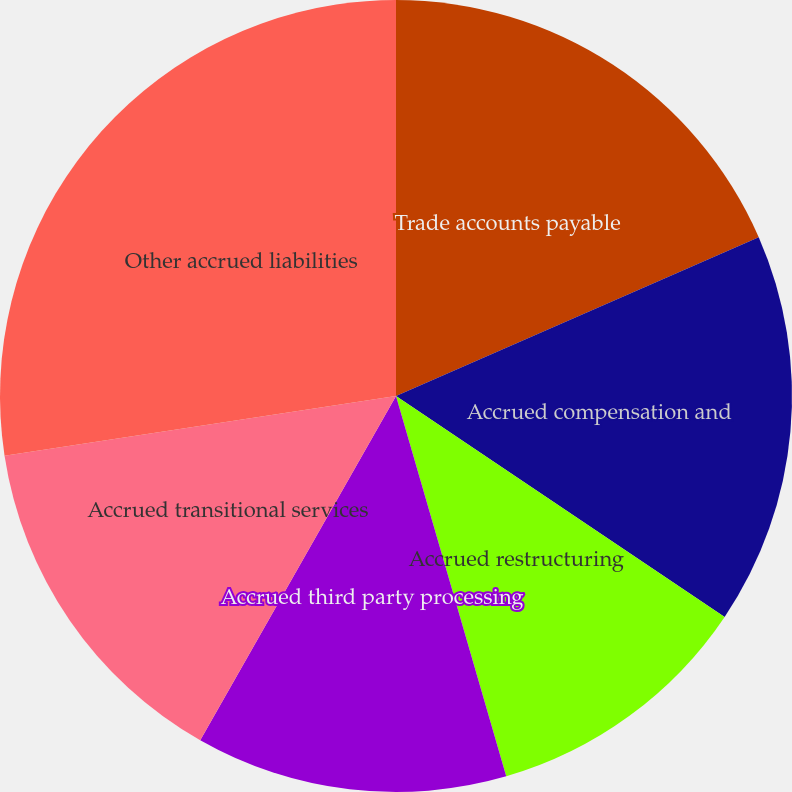Convert chart. <chart><loc_0><loc_0><loc_500><loc_500><pie_chart><fcel>Trade accounts payable<fcel>Accrued compensation and<fcel>Accrued restructuring<fcel>Accrued third party processing<fcel>Accrued transitional services<fcel>Other accrued liabilities<nl><fcel>18.43%<fcel>15.99%<fcel>11.09%<fcel>12.72%<fcel>14.36%<fcel>27.41%<nl></chart> 